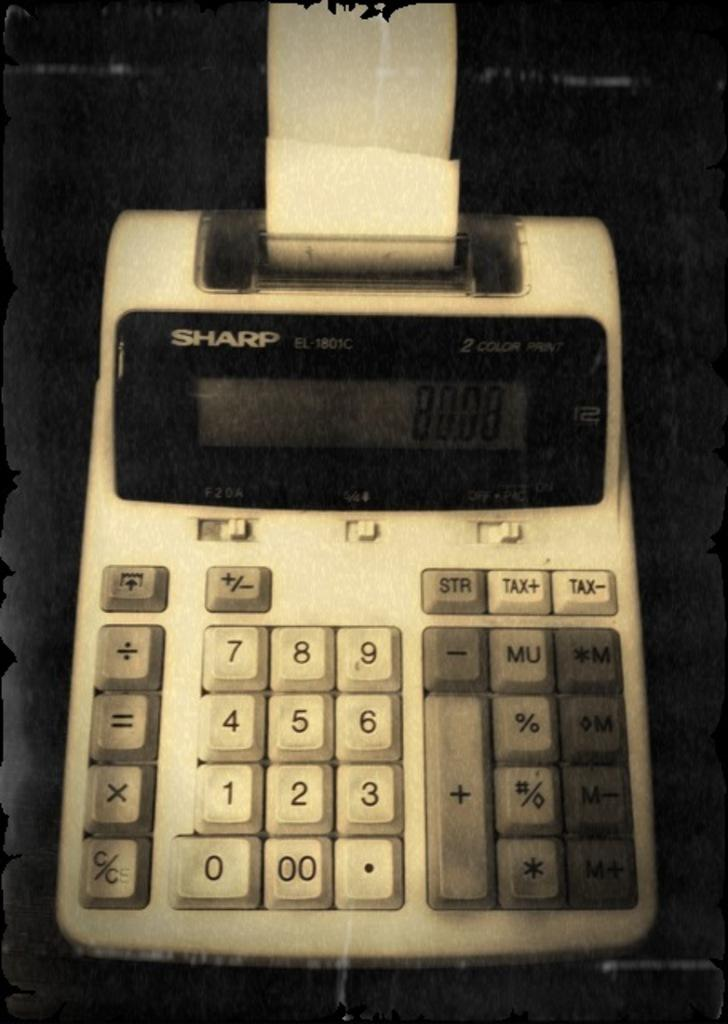<image>
Present a compact description of the photo's key features. A Sharp 2 color print device with paper in it sits on a table. 